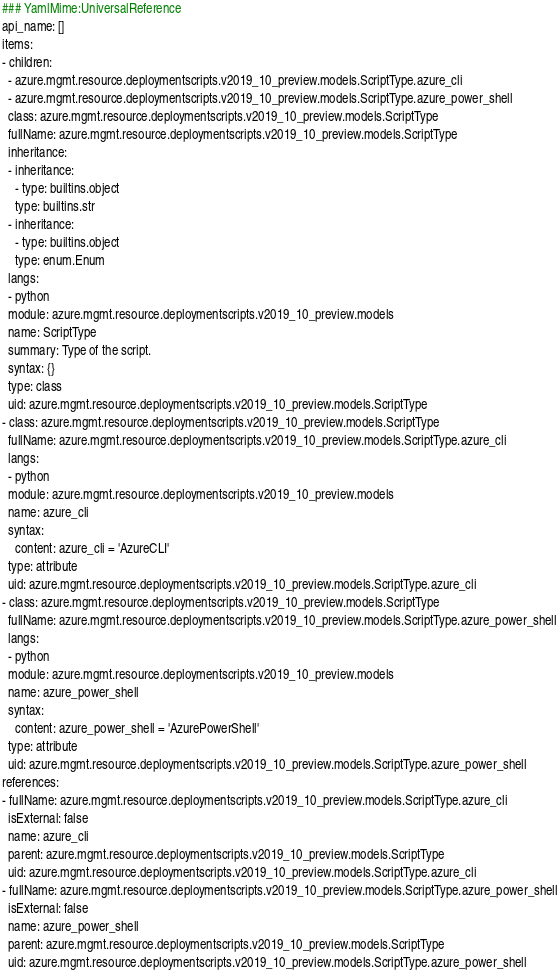Convert code to text. <code><loc_0><loc_0><loc_500><loc_500><_YAML_>### YamlMime:UniversalReference
api_name: []
items:
- children:
  - azure.mgmt.resource.deploymentscripts.v2019_10_preview.models.ScriptType.azure_cli
  - azure.mgmt.resource.deploymentscripts.v2019_10_preview.models.ScriptType.azure_power_shell
  class: azure.mgmt.resource.deploymentscripts.v2019_10_preview.models.ScriptType
  fullName: azure.mgmt.resource.deploymentscripts.v2019_10_preview.models.ScriptType
  inheritance:
  - inheritance:
    - type: builtins.object
    type: builtins.str
  - inheritance:
    - type: builtins.object
    type: enum.Enum
  langs:
  - python
  module: azure.mgmt.resource.deploymentscripts.v2019_10_preview.models
  name: ScriptType
  summary: Type of the script.
  syntax: {}
  type: class
  uid: azure.mgmt.resource.deploymentscripts.v2019_10_preview.models.ScriptType
- class: azure.mgmt.resource.deploymentscripts.v2019_10_preview.models.ScriptType
  fullName: azure.mgmt.resource.deploymentscripts.v2019_10_preview.models.ScriptType.azure_cli
  langs:
  - python
  module: azure.mgmt.resource.deploymentscripts.v2019_10_preview.models
  name: azure_cli
  syntax:
    content: azure_cli = 'AzureCLI'
  type: attribute
  uid: azure.mgmt.resource.deploymentscripts.v2019_10_preview.models.ScriptType.azure_cli
- class: azure.mgmt.resource.deploymentscripts.v2019_10_preview.models.ScriptType
  fullName: azure.mgmt.resource.deploymentscripts.v2019_10_preview.models.ScriptType.azure_power_shell
  langs:
  - python
  module: azure.mgmt.resource.deploymentscripts.v2019_10_preview.models
  name: azure_power_shell
  syntax:
    content: azure_power_shell = 'AzurePowerShell'
  type: attribute
  uid: azure.mgmt.resource.deploymentscripts.v2019_10_preview.models.ScriptType.azure_power_shell
references:
- fullName: azure.mgmt.resource.deploymentscripts.v2019_10_preview.models.ScriptType.azure_cli
  isExternal: false
  name: azure_cli
  parent: azure.mgmt.resource.deploymentscripts.v2019_10_preview.models.ScriptType
  uid: azure.mgmt.resource.deploymentscripts.v2019_10_preview.models.ScriptType.azure_cli
- fullName: azure.mgmt.resource.deploymentscripts.v2019_10_preview.models.ScriptType.azure_power_shell
  isExternal: false
  name: azure_power_shell
  parent: azure.mgmt.resource.deploymentscripts.v2019_10_preview.models.ScriptType
  uid: azure.mgmt.resource.deploymentscripts.v2019_10_preview.models.ScriptType.azure_power_shell
</code> 